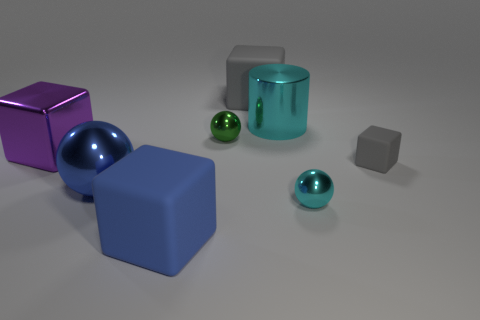Does the tiny gray cube have the same material as the purple thing?
Offer a very short reply. No. There is a thing that is in front of the tiny metallic thing that is in front of the tiny green object; what is its material?
Make the answer very short. Rubber. Are there more big blue metal spheres that are in front of the large blue block than big purple metal blocks?
Provide a short and direct response. No. What number of other things are the same size as the cyan shiny ball?
Keep it short and to the point. 2. Is the color of the large shiny cube the same as the large metallic cylinder?
Your response must be concise. No. There is a large matte cube that is behind the big rubber cube in front of the small gray object behind the large blue ball; what color is it?
Provide a succinct answer. Gray. What number of large gray cubes are on the left side of the large metallic object that is behind the tiny metal object behind the blue metal sphere?
Provide a succinct answer. 1. Is there anything else of the same color as the tiny matte thing?
Your response must be concise. Yes. There is a cyan ball that is behind the blue block; is it the same size as the green ball?
Ensure brevity in your answer.  Yes. There is a large rubber cube that is behind the blue block; how many large metallic cylinders are right of it?
Offer a very short reply. 1. 